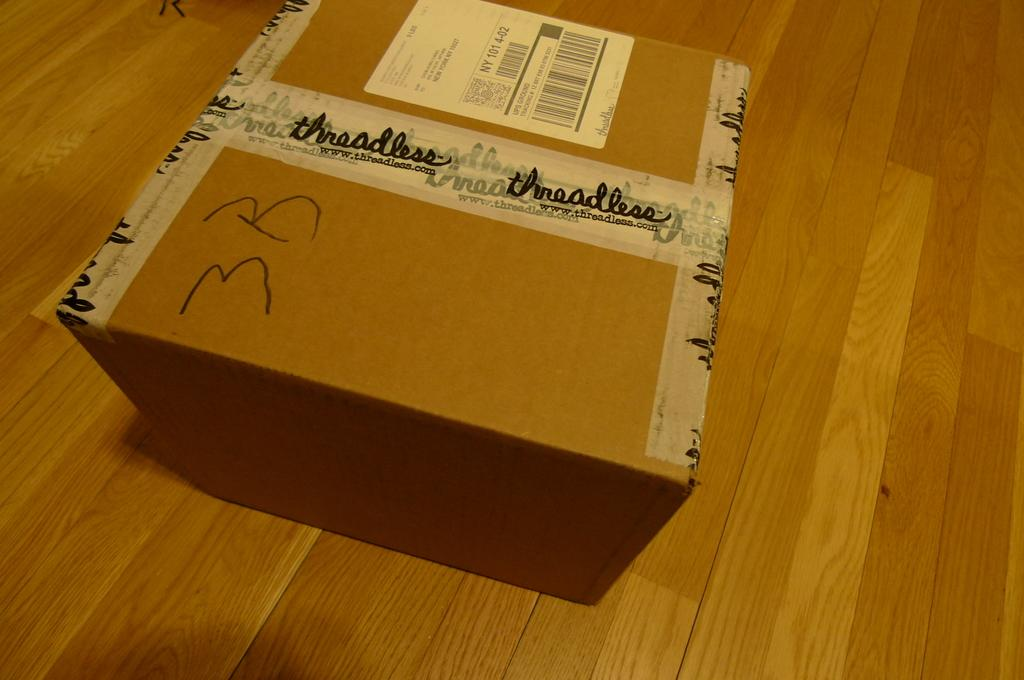<image>
Provide a brief description of the given image. A cardboard box sits on the floor sealed with Threadless tape. 